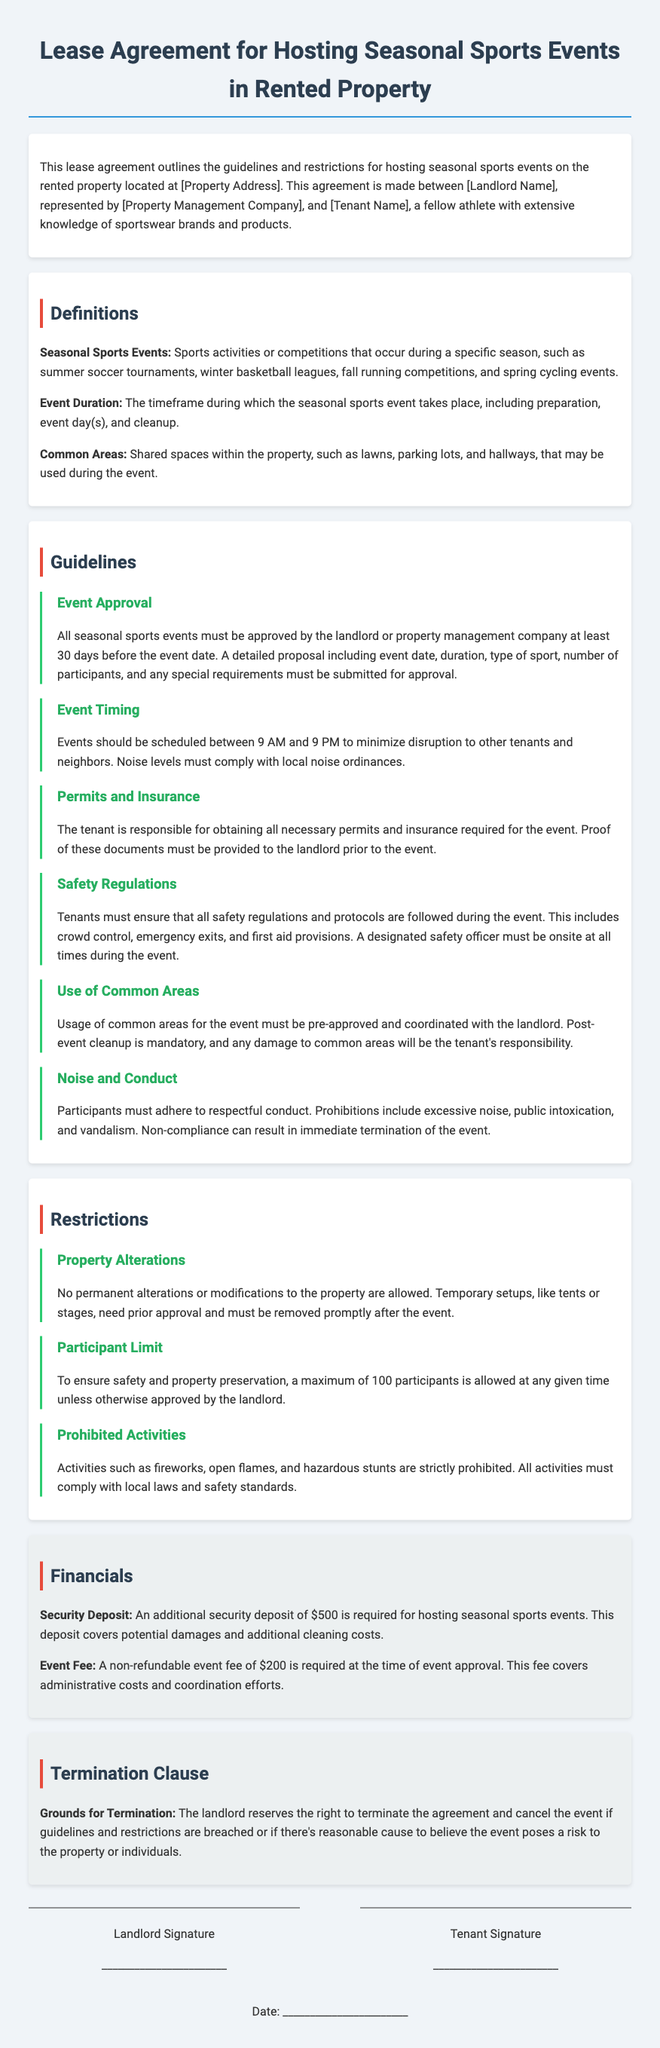What is the event approval notice period? The lease agreement states that all seasonal sports events must be approved at least 30 days before the event date.
Answer: 30 days What is the maximum number of participants allowed? The document specifies that a maximum of 100 participants is allowed at any given time unless approved otherwise.
Answer: 100 participants What is the non-refundable event fee? According to the financial section, the non-refundable event fee is required at the time of event approval.
Answer: $200 What are tenants responsible for regarding permits? The guidelines indicate that the tenant is responsible for obtaining all necessary permits and insurance for the event.
Answer: Obtaining permits What is required to ensure safety during the event? The guidelines dictate that a designated safety officer must be onsite at all times during the event for safety.
Answer: Safety officer What can happen if noise levels are excessive? Non-compliance with noise levels can result in the immediate termination of the event according to the noise and conduct guideline.
Answer: Immediate termination What is the security deposit amount? The financials section states that an additional security deposit is required for hosting seasonal sports events.
Answer: $500 Are temporary alterations allowed at the property? The restrictions section specifies that no permanent alterations or modifications to the property are allowed.
Answer: No permanent alterations What must be followed regarding participant conduct? The noise and conduct guidelines require participants to adhere to respectful conduct, with prohibitions outlined.
Answer: Respectful conduct 